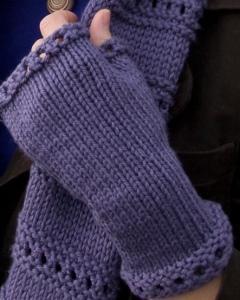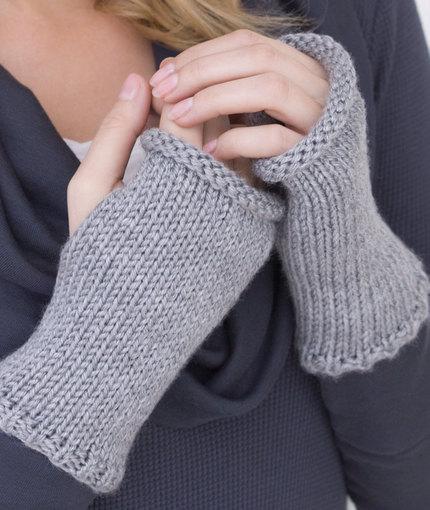The first image is the image on the left, the second image is the image on the right. Evaluate the accuracy of this statement regarding the images: "Both images feature a soild-colored fingerless yarn mitten modeled by a human hand.". Is it true? Answer yes or no. Yes. 